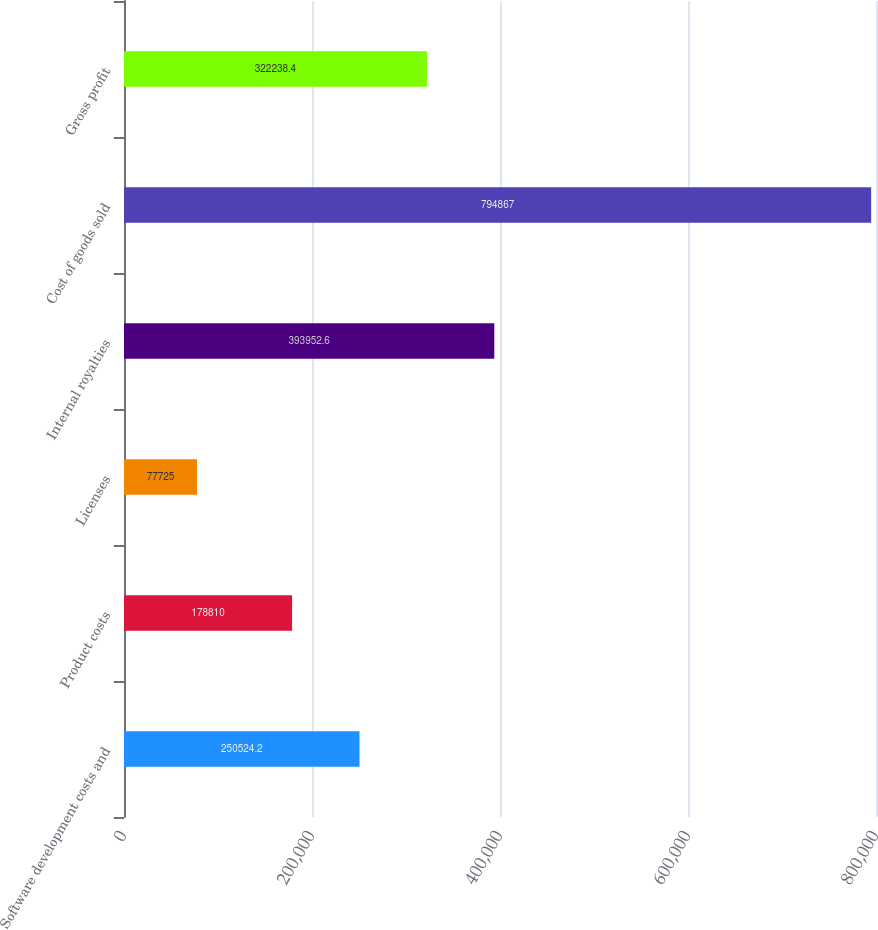<chart> <loc_0><loc_0><loc_500><loc_500><bar_chart><fcel>Software development costs and<fcel>Product costs<fcel>Licenses<fcel>Internal royalties<fcel>Cost of goods sold<fcel>Gross profit<nl><fcel>250524<fcel>178810<fcel>77725<fcel>393953<fcel>794867<fcel>322238<nl></chart> 